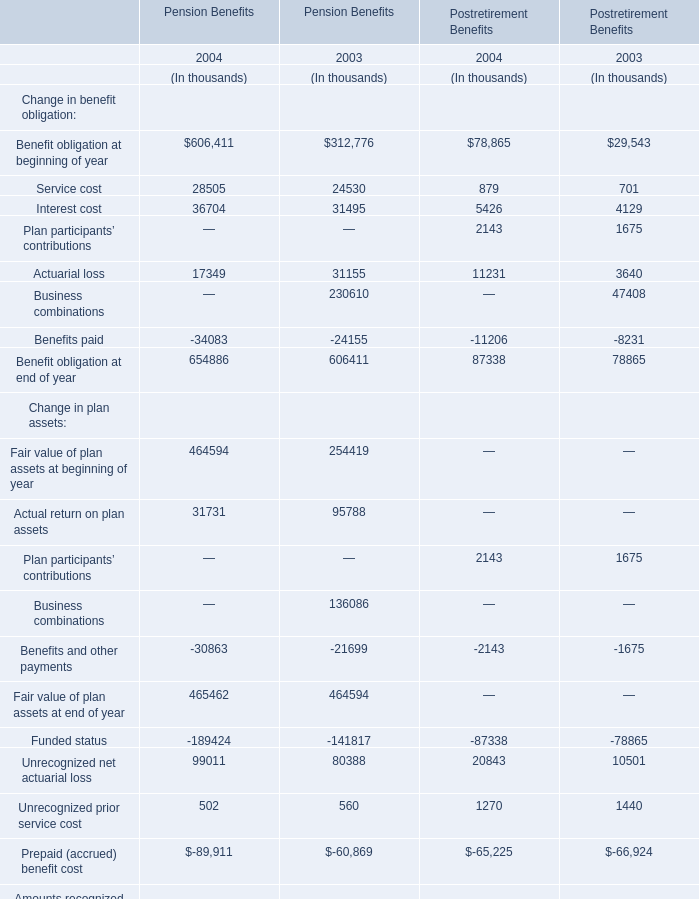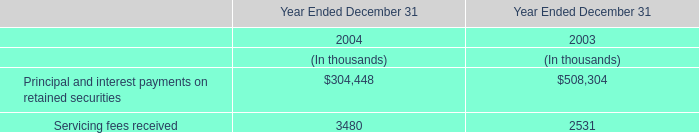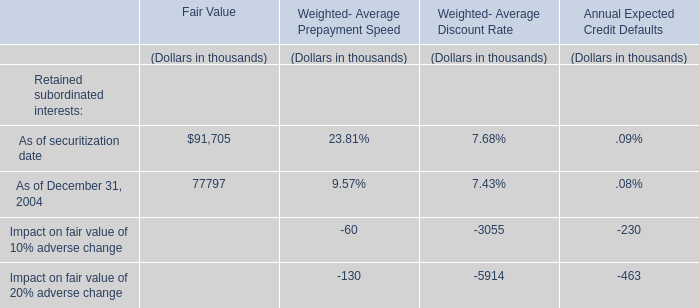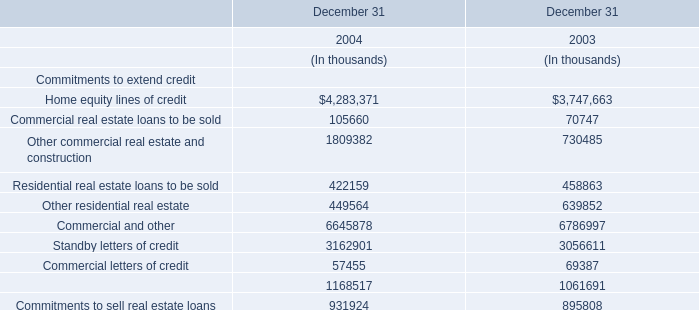What is the ratio of Actuarial loss of Pension Benefits in Table 0 to the Commercial letters of credit in Table 3 in 2003? 
Computations: (31155 / 69387)
Answer: 0.449. 